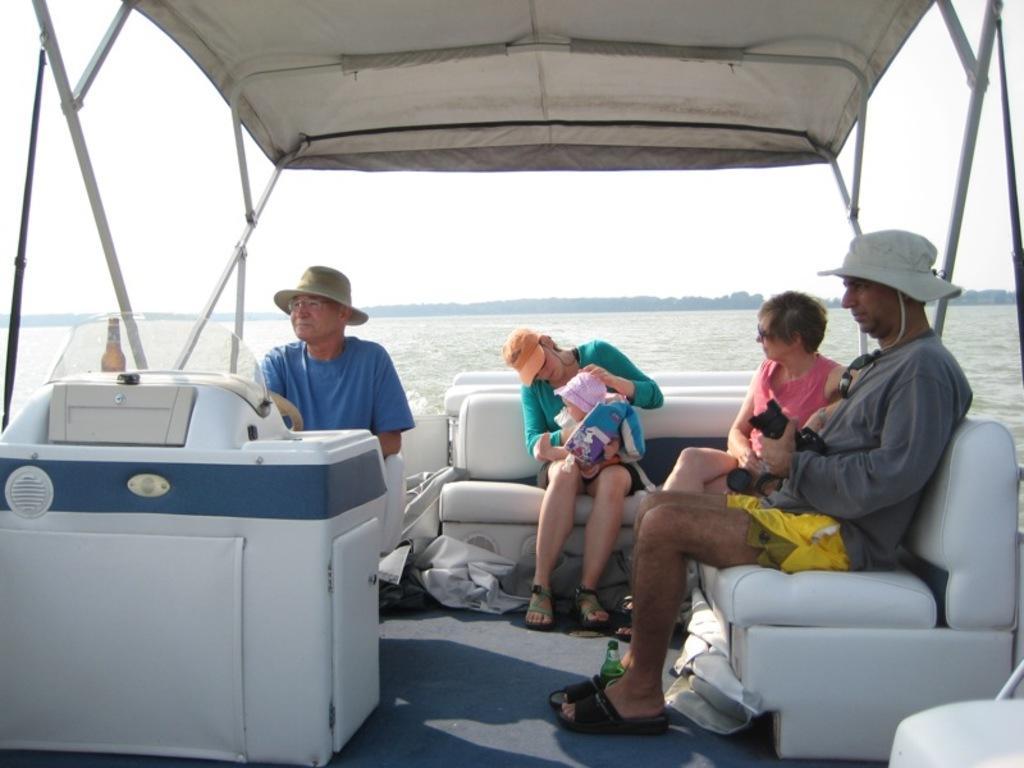Describe this image in one or two sentences. In this picture I can see there is a boat and there are few people sitting in the boat. The boat is sailing on the water and in the backdrop the sky is clear. 